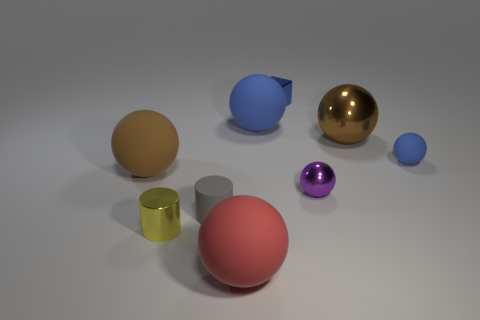What number of things are either tiny things that are behind the small purple metallic object or tiny yellow matte blocks?
Your response must be concise. 2. There is a rubber ball that is on the left side of the red matte ball; how big is it?
Keep it short and to the point. Large. Is the number of tiny cylinders less than the number of tiny blue shiny cylinders?
Ensure brevity in your answer.  No. Is the large object in front of the large brown matte sphere made of the same material as the brown ball that is to the right of the red object?
Keep it short and to the point. No. What shape is the large brown object right of the blue ball that is on the left side of the blue metallic thing that is right of the small gray rubber object?
Keep it short and to the point. Sphere. What number of yellow things have the same material as the gray object?
Keep it short and to the point. 0. What number of gray matte cylinders are on the right side of the tiny rubber object on the right side of the metallic cube?
Offer a very short reply. 0. There is a big thing right of the block; is its color the same as the rubber thing to the left of the small matte cylinder?
Offer a very short reply. Yes. There is a small shiny thing that is in front of the large blue rubber sphere and right of the red rubber ball; what is its shape?
Offer a very short reply. Sphere. Are there any other tiny things of the same shape as the small gray object?
Give a very brief answer. Yes. 